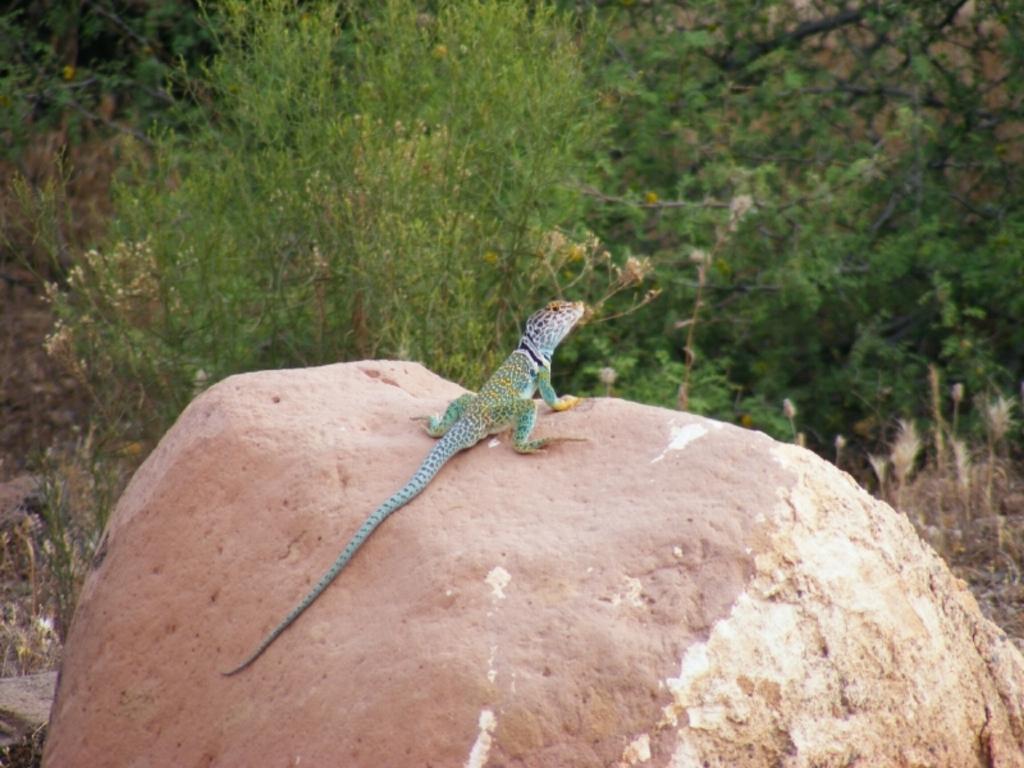In one or two sentences, can you explain what this image depicts? In this picture I can see a reptile on the rock, and in the background there are trees. 